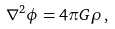Convert formula to latex. <formula><loc_0><loc_0><loc_500><loc_500>\nabla ^ { 2 } \phi = 4 \pi G \rho \, ,</formula> 